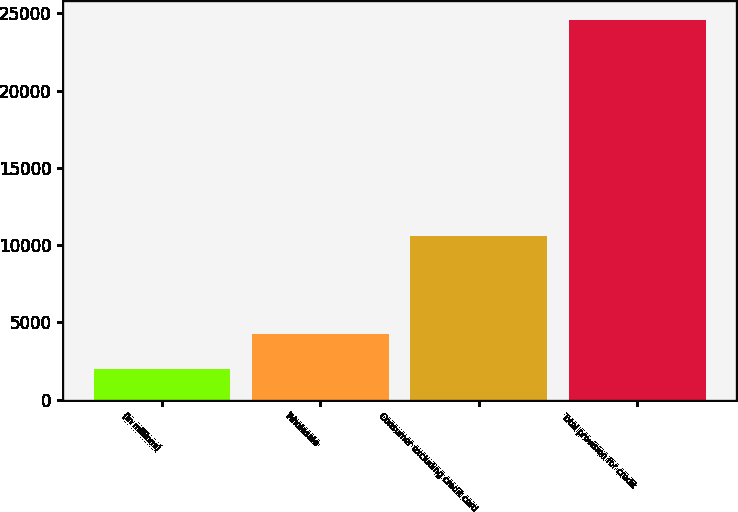Convert chart. <chart><loc_0><loc_0><loc_500><loc_500><bar_chart><fcel>(in millions)<fcel>Wholesale<fcel>Consumer excluding credit card<fcel>Total provision for credit<nl><fcel>2008<fcel>4266.3<fcel>10610<fcel>24591<nl></chart> 